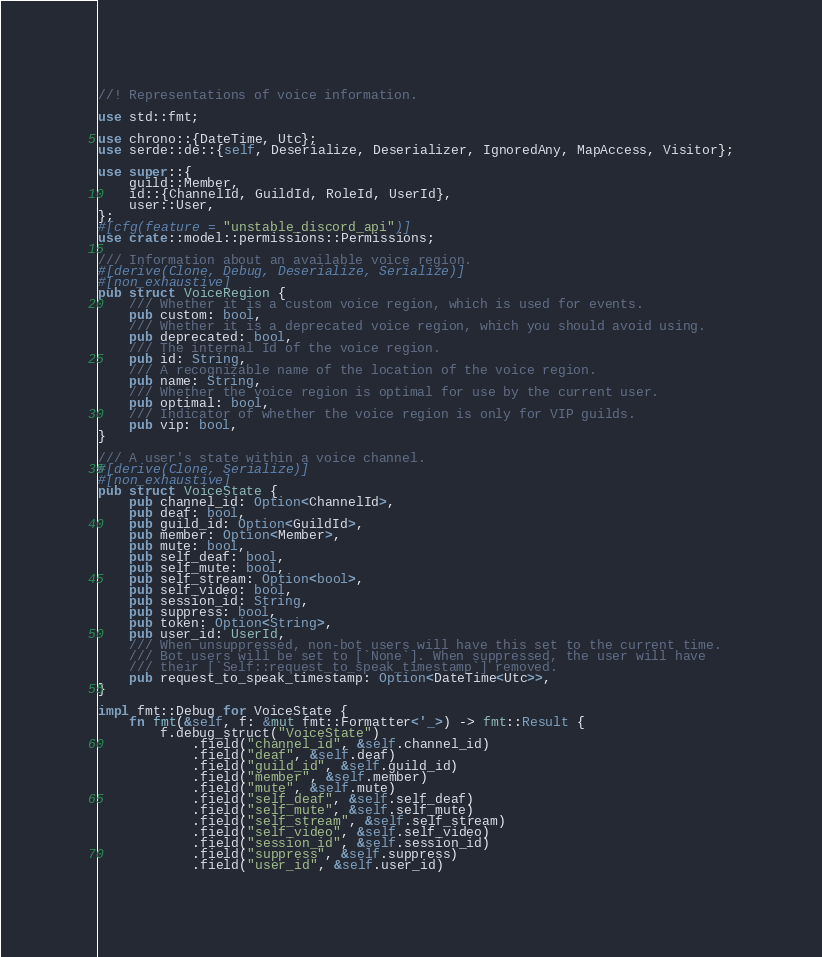Convert code to text. <code><loc_0><loc_0><loc_500><loc_500><_Rust_>//! Representations of voice information.

use std::fmt;

use chrono::{DateTime, Utc};
use serde::de::{self, Deserialize, Deserializer, IgnoredAny, MapAccess, Visitor};

use super::{
    guild::Member,
    id::{ChannelId, GuildId, RoleId, UserId},
    user::User,
};
#[cfg(feature = "unstable_discord_api")]
use crate::model::permissions::Permissions;

/// Information about an available voice region.
#[derive(Clone, Debug, Deserialize, Serialize)]
#[non_exhaustive]
pub struct VoiceRegion {
    /// Whether it is a custom voice region, which is used for events.
    pub custom: bool,
    /// Whether it is a deprecated voice region, which you should avoid using.
    pub deprecated: bool,
    /// The internal Id of the voice region.
    pub id: String,
    /// A recognizable name of the location of the voice region.
    pub name: String,
    /// Whether the voice region is optimal for use by the current user.
    pub optimal: bool,
    /// Indicator of whether the voice region is only for VIP guilds.
    pub vip: bool,
}

/// A user's state within a voice channel.
#[derive(Clone, Serialize)]
#[non_exhaustive]
pub struct VoiceState {
    pub channel_id: Option<ChannelId>,
    pub deaf: bool,
    pub guild_id: Option<GuildId>,
    pub member: Option<Member>,
    pub mute: bool,
    pub self_deaf: bool,
    pub self_mute: bool,
    pub self_stream: Option<bool>,
    pub self_video: bool,
    pub session_id: String,
    pub suppress: bool,
    pub token: Option<String>,
    pub user_id: UserId,
    /// When unsuppressed, non-bot users will have this set to the current time.
    /// Bot users will be set to [`None`]. When suppressed, the user will have
    /// their [`Self::request_to_speak_timestamp`] removed.
    pub request_to_speak_timestamp: Option<DateTime<Utc>>,
}

impl fmt::Debug for VoiceState {
    fn fmt(&self, f: &mut fmt::Formatter<'_>) -> fmt::Result {
        f.debug_struct("VoiceState")
            .field("channel_id", &self.channel_id)
            .field("deaf", &self.deaf)
            .field("guild_id", &self.guild_id)
            .field("member", &self.member)
            .field("mute", &self.mute)
            .field("self_deaf", &self.self_deaf)
            .field("self_mute", &self.self_mute)
            .field("self_stream", &self.self_stream)
            .field("self_video", &self.self_video)
            .field("session_id", &self.session_id)
            .field("suppress", &self.suppress)
            .field("user_id", &self.user_id)</code> 